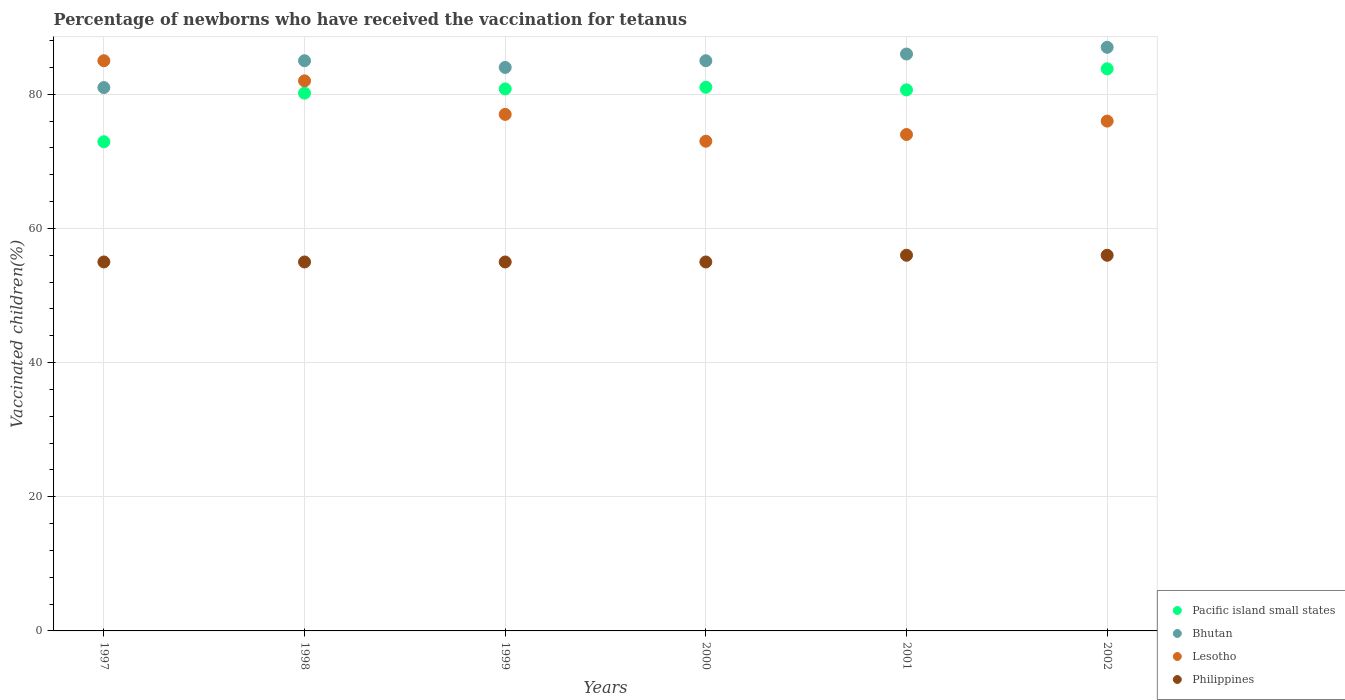How many different coloured dotlines are there?
Provide a short and direct response. 4. Is the number of dotlines equal to the number of legend labels?
Offer a very short reply. Yes. What is the percentage of vaccinated children in Philippines in 2000?
Ensure brevity in your answer.  55. Across all years, what is the maximum percentage of vaccinated children in Pacific island small states?
Your response must be concise. 83.8. Across all years, what is the minimum percentage of vaccinated children in Pacific island small states?
Offer a terse response. 72.92. In which year was the percentage of vaccinated children in Philippines maximum?
Your response must be concise. 2001. What is the total percentage of vaccinated children in Lesotho in the graph?
Give a very brief answer. 467. What is the difference between the percentage of vaccinated children in Pacific island small states in 1999 and that in 2002?
Keep it short and to the point. -3. What is the difference between the percentage of vaccinated children in Philippines in 1997 and the percentage of vaccinated children in Bhutan in 2000?
Your answer should be compact. -30. What is the average percentage of vaccinated children in Pacific island small states per year?
Your answer should be very brief. 79.9. In the year 2002, what is the difference between the percentage of vaccinated children in Philippines and percentage of vaccinated children in Bhutan?
Make the answer very short. -31. In how many years, is the percentage of vaccinated children in Philippines greater than 12 %?
Offer a very short reply. 6. What is the ratio of the percentage of vaccinated children in Philippines in 1999 to that in 2001?
Your answer should be compact. 0.98. Is the percentage of vaccinated children in Bhutan in 1999 less than that in 2000?
Offer a very short reply. Yes. What is the difference between the highest and the lowest percentage of vaccinated children in Pacific island small states?
Your response must be concise. 10.87. Is the sum of the percentage of vaccinated children in Philippines in 1997 and 2001 greater than the maximum percentage of vaccinated children in Lesotho across all years?
Your answer should be compact. Yes. Is the percentage of vaccinated children in Philippines strictly greater than the percentage of vaccinated children in Bhutan over the years?
Your response must be concise. No. What is the difference between two consecutive major ticks on the Y-axis?
Offer a terse response. 20. Are the values on the major ticks of Y-axis written in scientific E-notation?
Your answer should be compact. No. Does the graph contain grids?
Your answer should be compact. Yes. Where does the legend appear in the graph?
Keep it short and to the point. Bottom right. How many legend labels are there?
Your response must be concise. 4. What is the title of the graph?
Give a very brief answer. Percentage of newborns who have received the vaccination for tetanus. What is the label or title of the X-axis?
Provide a short and direct response. Years. What is the label or title of the Y-axis?
Offer a terse response. Vaccinated children(%). What is the Vaccinated children(%) in Pacific island small states in 1997?
Your response must be concise. 72.92. What is the Vaccinated children(%) of Lesotho in 1997?
Provide a succinct answer. 85. What is the Vaccinated children(%) in Pacific island small states in 1998?
Keep it short and to the point. 80.16. What is the Vaccinated children(%) in Bhutan in 1998?
Provide a succinct answer. 85. What is the Vaccinated children(%) of Pacific island small states in 1999?
Offer a terse response. 80.8. What is the Vaccinated children(%) of Bhutan in 1999?
Your answer should be compact. 84. What is the Vaccinated children(%) in Lesotho in 1999?
Provide a succinct answer. 77. What is the Vaccinated children(%) of Pacific island small states in 2000?
Make the answer very short. 81.04. What is the Vaccinated children(%) in Bhutan in 2000?
Keep it short and to the point. 85. What is the Vaccinated children(%) in Philippines in 2000?
Provide a short and direct response. 55. What is the Vaccinated children(%) in Pacific island small states in 2001?
Keep it short and to the point. 80.65. What is the Vaccinated children(%) of Bhutan in 2001?
Make the answer very short. 86. What is the Vaccinated children(%) of Pacific island small states in 2002?
Provide a succinct answer. 83.8. What is the Vaccinated children(%) in Lesotho in 2002?
Make the answer very short. 76. What is the Vaccinated children(%) in Philippines in 2002?
Your answer should be compact. 56. Across all years, what is the maximum Vaccinated children(%) of Pacific island small states?
Provide a short and direct response. 83.8. Across all years, what is the maximum Vaccinated children(%) of Bhutan?
Offer a terse response. 87. Across all years, what is the maximum Vaccinated children(%) of Lesotho?
Give a very brief answer. 85. Across all years, what is the minimum Vaccinated children(%) of Pacific island small states?
Provide a succinct answer. 72.92. Across all years, what is the minimum Vaccinated children(%) of Bhutan?
Provide a succinct answer. 81. What is the total Vaccinated children(%) of Pacific island small states in the graph?
Ensure brevity in your answer.  479.38. What is the total Vaccinated children(%) of Bhutan in the graph?
Offer a very short reply. 508. What is the total Vaccinated children(%) of Lesotho in the graph?
Your response must be concise. 467. What is the total Vaccinated children(%) in Philippines in the graph?
Your answer should be very brief. 332. What is the difference between the Vaccinated children(%) in Pacific island small states in 1997 and that in 1998?
Provide a succinct answer. -7.24. What is the difference between the Vaccinated children(%) of Bhutan in 1997 and that in 1998?
Give a very brief answer. -4. What is the difference between the Vaccinated children(%) of Lesotho in 1997 and that in 1998?
Provide a succinct answer. 3. What is the difference between the Vaccinated children(%) of Philippines in 1997 and that in 1998?
Provide a succinct answer. 0. What is the difference between the Vaccinated children(%) of Pacific island small states in 1997 and that in 1999?
Offer a very short reply. -7.88. What is the difference between the Vaccinated children(%) of Lesotho in 1997 and that in 1999?
Your answer should be compact. 8. What is the difference between the Vaccinated children(%) of Philippines in 1997 and that in 1999?
Keep it short and to the point. 0. What is the difference between the Vaccinated children(%) in Pacific island small states in 1997 and that in 2000?
Offer a terse response. -8.12. What is the difference between the Vaccinated children(%) of Bhutan in 1997 and that in 2000?
Your response must be concise. -4. What is the difference between the Vaccinated children(%) in Pacific island small states in 1997 and that in 2001?
Provide a succinct answer. -7.73. What is the difference between the Vaccinated children(%) in Bhutan in 1997 and that in 2001?
Keep it short and to the point. -5. What is the difference between the Vaccinated children(%) in Philippines in 1997 and that in 2001?
Provide a succinct answer. -1. What is the difference between the Vaccinated children(%) in Pacific island small states in 1997 and that in 2002?
Provide a succinct answer. -10.87. What is the difference between the Vaccinated children(%) in Bhutan in 1997 and that in 2002?
Offer a very short reply. -6. What is the difference between the Vaccinated children(%) in Pacific island small states in 1998 and that in 1999?
Ensure brevity in your answer.  -0.63. What is the difference between the Vaccinated children(%) of Bhutan in 1998 and that in 1999?
Your response must be concise. 1. What is the difference between the Vaccinated children(%) in Pacific island small states in 1998 and that in 2000?
Provide a succinct answer. -0.88. What is the difference between the Vaccinated children(%) in Pacific island small states in 1998 and that in 2001?
Your answer should be compact. -0.49. What is the difference between the Vaccinated children(%) in Philippines in 1998 and that in 2001?
Your answer should be compact. -1. What is the difference between the Vaccinated children(%) of Pacific island small states in 1998 and that in 2002?
Provide a short and direct response. -3.63. What is the difference between the Vaccinated children(%) of Bhutan in 1998 and that in 2002?
Make the answer very short. -2. What is the difference between the Vaccinated children(%) in Lesotho in 1998 and that in 2002?
Give a very brief answer. 6. What is the difference between the Vaccinated children(%) of Pacific island small states in 1999 and that in 2000?
Provide a succinct answer. -0.25. What is the difference between the Vaccinated children(%) in Bhutan in 1999 and that in 2000?
Provide a succinct answer. -1. What is the difference between the Vaccinated children(%) of Lesotho in 1999 and that in 2000?
Offer a very short reply. 4. What is the difference between the Vaccinated children(%) of Pacific island small states in 1999 and that in 2001?
Your response must be concise. 0.14. What is the difference between the Vaccinated children(%) in Lesotho in 1999 and that in 2001?
Give a very brief answer. 3. What is the difference between the Vaccinated children(%) in Philippines in 1999 and that in 2001?
Keep it short and to the point. -1. What is the difference between the Vaccinated children(%) of Pacific island small states in 1999 and that in 2002?
Give a very brief answer. -3. What is the difference between the Vaccinated children(%) of Bhutan in 1999 and that in 2002?
Offer a terse response. -3. What is the difference between the Vaccinated children(%) of Philippines in 1999 and that in 2002?
Your answer should be compact. -1. What is the difference between the Vaccinated children(%) in Pacific island small states in 2000 and that in 2001?
Keep it short and to the point. 0.39. What is the difference between the Vaccinated children(%) in Philippines in 2000 and that in 2001?
Keep it short and to the point. -1. What is the difference between the Vaccinated children(%) of Pacific island small states in 2000 and that in 2002?
Your response must be concise. -2.75. What is the difference between the Vaccinated children(%) in Lesotho in 2000 and that in 2002?
Keep it short and to the point. -3. What is the difference between the Vaccinated children(%) of Pacific island small states in 2001 and that in 2002?
Offer a terse response. -3.14. What is the difference between the Vaccinated children(%) in Lesotho in 2001 and that in 2002?
Make the answer very short. -2. What is the difference between the Vaccinated children(%) of Pacific island small states in 1997 and the Vaccinated children(%) of Bhutan in 1998?
Ensure brevity in your answer.  -12.08. What is the difference between the Vaccinated children(%) in Pacific island small states in 1997 and the Vaccinated children(%) in Lesotho in 1998?
Your response must be concise. -9.08. What is the difference between the Vaccinated children(%) of Pacific island small states in 1997 and the Vaccinated children(%) of Philippines in 1998?
Keep it short and to the point. 17.92. What is the difference between the Vaccinated children(%) of Lesotho in 1997 and the Vaccinated children(%) of Philippines in 1998?
Your answer should be compact. 30. What is the difference between the Vaccinated children(%) in Pacific island small states in 1997 and the Vaccinated children(%) in Bhutan in 1999?
Your response must be concise. -11.08. What is the difference between the Vaccinated children(%) of Pacific island small states in 1997 and the Vaccinated children(%) of Lesotho in 1999?
Offer a very short reply. -4.08. What is the difference between the Vaccinated children(%) in Pacific island small states in 1997 and the Vaccinated children(%) in Philippines in 1999?
Keep it short and to the point. 17.92. What is the difference between the Vaccinated children(%) of Bhutan in 1997 and the Vaccinated children(%) of Philippines in 1999?
Keep it short and to the point. 26. What is the difference between the Vaccinated children(%) in Lesotho in 1997 and the Vaccinated children(%) in Philippines in 1999?
Provide a short and direct response. 30. What is the difference between the Vaccinated children(%) in Pacific island small states in 1997 and the Vaccinated children(%) in Bhutan in 2000?
Provide a short and direct response. -12.08. What is the difference between the Vaccinated children(%) in Pacific island small states in 1997 and the Vaccinated children(%) in Lesotho in 2000?
Your answer should be very brief. -0.08. What is the difference between the Vaccinated children(%) in Pacific island small states in 1997 and the Vaccinated children(%) in Philippines in 2000?
Keep it short and to the point. 17.92. What is the difference between the Vaccinated children(%) of Lesotho in 1997 and the Vaccinated children(%) of Philippines in 2000?
Ensure brevity in your answer.  30. What is the difference between the Vaccinated children(%) in Pacific island small states in 1997 and the Vaccinated children(%) in Bhutan in 2001?
Make the answer very short. -13.08. What is the difference between the Vaccinated children(%) of Pacific island small states in 1997 and the Vaccinated children(%) of Lesotho in 2001?
Keep it short and to the point. -1.08. What is the difference between the Vaccinated children(%) in Pacific island small states in 1997 and the Vaccinated children(%) in Philippines in 2001?
Offer a terse response. 16.92. What is the difference between the Vaccinated children(%) of Bhutan in 1997 and the Vaccinated children(%) of Philippines in 2001?
Provide a succinct answer. 25. What is the difference between the Vaccinated children(%) of Pacific island small states in 1997 and the Vaccinated children(%) of Bhutan in 2002?
Your response must be concise. -14.08. What is the difference between the Vaccinated children(%) of Pacific island small states in 1997 and the Vaccinated children(%) of Lesotho in 2002?
Keep it short and to the point. -3.08. What is the difference between the Vaccinated children(%) in Pacific island small states in 1997 and the Vaccinated children(%) in Philippines in 2002?
Your response must be concise. 16.92. What is the difference between the Vaccinated children(%) of Bhutan in 1997 and the Vaccinated children(%) of Lesotho in 2002?
Your response must be concise. 5. What is the difference between the Vaccinated children(%) of Lesotho in 1997 and the Vaccinated children(%) of Philippines in 2002?
Provide a succinct answer. 29. What is the difference between the Vaccinated children(%) of Pacific island small states in 1998 and the Vaccinated children(%) of Bhutan in 1999?
Your answer should be very brief. -3.84. What is the difference between the Vaccinated children(%) of Pacific island small states in 1998 and the Vaccinated children(%) of Lesotho in 1999?
Your response must be concise. 3.16. What is the difference between the Vaccinated children(%) in Pacific island small states in 1998 and the Vaccinated children(%) in Philippines in 1999?
Provide a succinct answer. 25.16. What is the difference between the Vaccinated children(%) of Bhutan in 1998 and the Vaccinated children(%) of Lesotho in 1999?
Your answer should be very brief. 8. What is the difference between the Vaccinated children(%) in Bhutan in 1998 and the Vaccinated children(%) in Philippines in 1999?
Give a very brief answer. 30. What is the difference between the Vaccinated children(%) in Lesotho in 1998 and the Vaccinated children(%) in Philippines in 1999?
Your answer should be compact. 27. What is the difference between the Vaccinated children(%) of Pacific island small states in 1998 and the Vaccinated children(%) of Bhutan in 2000?
Make the answer very short. -4.84. What is the difference between the Vaccinated children(%) of Pacific island small states in 1998 and the Vaccinated children(%) of Lesotho in 2000?
Provide a succinct answer. 7.16. What is the difference between the Vaccinated children(%) in Pacific island small states in 1998 and the Vaccinated children(%) in Philippines in 2000?
Offer a terse response. 25.16. What is the difference between the Vaccinated children(%) of Bhutan in 1998 and the Vaccinated children(%) of Lesotho in 2000?
Your answer should be very brief. 12. What is the difference between the Vaccinated children(%) in Bhutan in 1998 and the Vaccinated children(%) in Philippines in 2000?
Keep it short and to the point. 30. What is the difference between the Vaccinated children(%) of Lesotho in 1998 and the Vaccinated children(%) of Philippines in 2000?
Provide a succinct answer. 27. What is the difference between the Vaccinated children(%) of Pacific island small states in 1998 and the Vaccinated children(%) of Bhutan in 2001?
Keep it short and to the point. -5.84. What is the difference between the Vaccinated children(%) in Pacific island small states in 1998 and the Vaccinated children(%) in Lesotho in 2001?
Provide a short and direct response. 6.16. What is the difference between the Vaccinated children(%) in Pacific island small states in 1998 and the Vaccinated children(%) in Philippines in 2001?
Provide a succinct answer. 24.16. What is the difference between the Vaccinated children(%) of Bhutan in 1998 and the Vaccinated children(%) of Lesotho in 2001?
Provide a short and direct response. 11. What is the difference between the Vaccinated children(%) in Lesotho in 1998 and the Vaccinated children(%) in Philippines in 2001?
Offer a very short reply. 26. What is the difference between the Vaccinated children(%) in Pacific island small states in 1998 and the Vaccinated children(%) in Bhutan in 2002?
Provide a short and direct response. -6.84. What is the difference between the Vaccinated children(%) of Pacific island small states in 1998 and the Vaccinated children(%) of Lesotho in 2002?
Ensure brevity in your answer.  4.16. What is the difference between the Vaccinated children(%) in Pacific island small states in 1998 and the Vaccinated children(%) in Philippines in 2002?
Keep it short and to the point. 24.16. What is the difference between the Vaccinated children(%) of Bhutan in 1998 and the Vaccinated children(%) of Lesotho in 2002?
Your response must be concise. 9. What is the difference between the Vaccinated children(%) in Lesotho in 1998 and the Vaccinated children(%) in Philippines in 2002?
Offer a very short reply. 26. What is the difference between the Vaccinated children(%) of Pacific island small states in 1999 and the Vaccinated children(%) of Bhutan in 2000?
Give a very brief answer. -4.2. What is the difference between the Vaccinated children(%) of Pacific island small states in 1999 and the Vaccinated children(%) of Lesotho in 2000?
Your answer should be compact. 7.8. What is the difference between the Vaccinated children(%) of Pacific island small states in 1999 and the Vaccinated children(%) of Philippines in 2000?
Keep it short and to the point. 25.8. What is the difference between the Vaccinated children(%) in Bhutan in 1999 and the Vaccinated children(%) in Lesotho in 2000?
Your answer should be very brief. 11. What is the difference between the Vaccinated children(%) of Bhutan in 1999 and the Vaccinated children(%) of Philippines in 2000?
Offer a terse response. 29. What is the difference between the Vaccinated children(%) in Pacific island small states in 1999 and the Vaccinated children(%) in Bhutan in 2001?
Offer a very short reply. -5.2. What is the difference between the Vaccinated children(%) of Pacific island small states in 1999 and the Vaccinated children(%) of Lesotho in 2001?
Your answer should be compact. 6.8. What is the difference between the Vaccinated children(%) in Pacific island small states in 1999 and the Vaccinated children(%) in Philippines in 2001?
Give a very brief answer. 24.8. What is the difference between the Vaccinated children(%) of Lesotho in 1999 and the Vaccinated children(%) of Philippines in 2001?
Your response must be concise. 21. What is the difference between the Vaccinated children(%) of Pacific island small states in 1999 and the Vaccinated children(%) of Bhutan in 2002?
Your answer should be very brief. -6.2. What is the difference between the Vaccinated children(%) in Pacific island small states in 1999 and the Vaccinated children(%) in Lesotho in 2002?
Keep it short and to the point. 4.8. What is the difference between the Vaccinated children(%) in Pacific island small states in 1999 and the Vaccinated children(%) in Philippines in 2002?
Your response must be concise. 24.8. What is the difference between the Vaccinated children(%) of Lesotho in 1999 and the Vaccinated children(%) of Philippines in 2002?
Ensure brevity in your answer.  21. What is the difference between the Vaccinated children(%) in Pacific island small states in 2000 and the Vaccinated children(%) in Bhutan in 2001?
Offer a very short reply. -4.96. What is the difference between the Vaccinated children(%) in Pacific island small states in 2000 and the Vaccinated children(%) in Lesotho in 2001?
Provide a short and direct response. 7.04. What is the difference between the Vaccinated children(%) of Pacific island small states in 2000 and the Vaccinated children(%) of Philippines in 2001?
Make the answer very short. 25.04. What is the difference between the Vaccinated children(%) of Bhutan in 2000 and the Vaccinated children(%) of Lesotho in 2001?
Your answer should be compact. 11. What is the difference between the Vaccinated children(%) of Lesotho in 2000 and the Vaccinated children(%) of Philippines in 2001?
Your response must be concise. 17. What is the difference between the Vaccinated children(%) in Pacific island small states in 2000 and the Vaccinated children(%) in Bhutan in 2002?
Your answer should be compact. -5.96. What is the difference between the Vaccinated children(%) of Pacific island small states in 2000 and the Vaccinated children(%) of Lesotho in 2002?
Your answer should be very brief. 5.04. What is the difference between the Vaccinated children(%) in Pacific island small states in 2000 and the Vaccinated children(%) in Philippines in 2002?
Your answer should be very brief. 25.04. What is the difference between the Vaccinated children(%) in Bhutan in 2000 and the Vaccinated children(%) in Philippines in 2002?
Ensure brevity in your answer.  29. What is the difference between the Vaccinated children(%) of Pacific island small states in 2001 and the Vaccinated children(%) of Bhutan in 2002?
Offer a terse response. -6.34. What is the difference between the Vaccinated children(%) of Pacific island small states in 2001 and the Vaccinated children(%) of Lesotho in 2002?
Your response must be concise. 4.66. What is the difference between the Vaccinated children(%) in Pacific island small states in 2001 and the Vaccinated children(%) in Philippines in 2002?
Your answer should be very brief. 24.66. What is the difference between the Vaccinated children(%) of Bhutan in 2001 and the Vaccinated children(%) of Philippines in 2002?
Your response must be concise. 30. What is the difference between the Vaccinated children(%) in Lesotho in 2001 and the Vaccinated children(%) in Philippines in 2002?
Give a very brief answer. 18. What is the average Vaccinated children(%) in Pacific island small states per year?
Ensure brevity in your answer.  79.9. What is the average Vaccinated children(%) of Bhutan per year?
Offer a terse response. 84.67. What is the average Vaccinated children(%) in Lesotho per year?
Your answer should be very brief. 77.83. What is the average Vaccinated children(%) of Philippines per year?
Give a very brief answer. 55.33. In the year 1997, what is the difference between the Vaccinated children(%) in Pacific island small states and Vaccinated children(%) in Bhutan?
Your answer should be compact. -8.08. In the year 1997, what is the difference between the Vaccinated children(%) of Pacific island small states and Vaccinated children(%) of Lesotho?
Offer a very short reply. -12.08. In the year 1997, what is the difference between the Vaccinated children(%) of Pacific island small states and Vaccinated children(%) of Philippines?
Give a very brief answer. 17.92. In the year 1997, what is the difference between the Vaccinated children(%) of Bhutan and Vaccinated children(%) of Lesotho?
Your response must be concise. -4. In the year 1997, what is the difference between the Vaccinated children(%) in Bhutan and Vaccinated children(%) in Philippines?
Make the answer very short. 26. In the year 1998, what is the difference between the Vaccinated children(%) of Pacific island small states and Vaccinated children(%) of Bhutan?
Your answer should be compact. -4.84. In the year 1998, what is the difference between the Vaccinated children(%) in Pacific island small states and Vaccinated children(%) in Lesotho?
Your answer should be compact. -1.84. In the year 1998, what is the difference between the Vaccinated children(%) of Pacific island small states and Vaccinated children(%) of Philippines?
Give a very brief answer. 25.16. In the year 1998, what is the difference between the Vaccinated children(%) in Bhutan and Vaccinated children(%) in Lesotho?
Provide a short and direct response. 3. In the year 1998, what is the difference between the Vaccinated children(%) in Lesotho and Vaccinated children(%) in Philippines?
Make the answer very short. 27. In the year 1999, what is the difference between the Vaccinated children(%) in Pacific island small states and Vaccinated children(%) in Bhutan?
Your response must be concise. -3.2. In the year 1999, what is the difference between the Vaccinated children(%) of Pacific island small states and Vaccinated children(%) of Lesotho?
Ensure brevity in your answer.  3.8. In the year 1999, what is the difference between the Vaccinated children(%) in Pacific island small states and Vaccinated children(%) in Philippines?
Your answer should be compact. 25.8. In the year 1999, what is the difference between the Vaccinated children(%) in Bhutan and Vaccinated children(%) in Philippines?
Offer a terse response. 29. In the year 2000, what is the difference between the Vaccinated children(%) of Pacific island small states and Vaccinated children(%) of Bhutan?
Ensure brevity in your answer.  -3.96. In the year 2000, what is the difference between the Vaccinated children(%) in Pacific island small states and Vaccinated children(%) in Lesotho?
Give a very brief answer. 8.04. In the year 2000, what is the difference between the Vaccinated children(%) of Pacific island small states and Vaccinated children(%) of Philippines?
Give a very brief answer. 26.04. In the year 2000, what is the difference between the Vaccinated children(%) in Lesotho and Vaccinated children(%) in Philippines?
Keep it short and to the point. 18. In the year 2001, what is the difference between the Vaccinated children(%) of Pacific island small states and Vaccinated children(%) of Bhutan?
Your answer should be very brief. -5.34. In the year 2001, what is the difference between the Vaccinated children(%) of Pacific island small states and Vaccinated children(%) of Lesotho?
Your response must be concise. 6.66. In the year 2001, what is the difference between the Vaccinated children(%) in Pacific island small states and Vaccinated children(%) in Philippines?
Provide a short and direct response. 24.66. In the year 2001, what is the difference between the Vaccinated children(%) of Lesotho and Vaccinated children(%) of Philippines?
Give a very brief answer. 18. In the year 2002, what is the difference between the Vaccinated children(%) in Pacific island small states and Vaccinated children(%) in Bhutan?
Make the answer very short. -3.2. In the year 2002, what is the difference between the Vaccinated children(%) of Pacific island small states and Vaccinated children(%) of Lesotho?
Keep it short and to the point. 7.8. In the year 2002, what is the difference between the Vaccinated children(%) in Pacific island small states and Vaccinated children(%) in Philippines?
Your answer should be very brief. 27.8. What is the ratio of the Vaccinated children(%) in Pacific island small states in 1997 to that in 1998?
Give a very brief answer. 0.91. What is the ratio of the Vaccinated children(%) of Bhutan in 1997 to that in 1998?
Offer a very short reply. 0.95. What is the ratio of the Vaccinated children(%) of Lesotho in 1997 to that in 1998?
Your response must be concise. 1.04. What is the ratio of the Vaccinated children(%) of Philippines in 1997 to that in 1998?
Make the answer very short. 1. What is the ratio of the Vaccinated children(%) in Pacific island small states in 1997 to that in 1999?
Ensure brevity in your answer.  0.9. What is the ratio of the Vaccinated children(%) of Lesotho in 1997 to that in 1999?
Offer a very short reply. 1.1. What is the ratio of the Vaccinated children(%) in Pacific island small states in 1997 to that in 2000?
Ensure brevity in your answer.  0.9. What is the ratio of the Vaccinated children(%) in Bhutan in 1997 to that in 2000?
Provide a succinct answer. 0.95. What is the ratio of the Vaccinated children(%) of Lesotho in 1997 to that in 2000?
Offer a very short reply. 1.16. What is the ratio of the Vaccinated children(%) of Philippines in 1997 to that in 2000?
Provide a succinct answer. 1. What is the ratio of the Vaccinated children(%) in Pacific island small states in 1997 to that in 2001?
Keep it short and to the point. 0.9. What is the ratio of the Vaccinated children(%) in Bhutan in 1997 to that in 2001?
Offer a terse response. 0.94. What is the ratio of the Vaccinated children(%) of Lesotho in 1997 to that in 2001?
Provide a short and direct response. 1.15. What is the ratio of the Vaccinated children(%) in Philippines in 1997 to that in 2001?
Make the answer very short. 0.98. What is the ratio of the Vaccinated children(%) in Pacific island small states in 1997 to that in 2002?
Provide a short and direct response. 0.87. What is the ratio of the Vaccinated children(%) of Lesotho in 1997 to that in 2002?
Provide a succinct answer. 1.12. What is the ratio of the Vaccinated children(%) of Philippines in 1997 to that in 2002?
Offer a very short reply. 0.98. What is the ratio of the Vaccinated children(%) of Pacific island small states in 1998 to that in 1999?
Provide a succinct answer. 0.99. What is the ratio of the Vaccinated children(%) in Bhutan in 1998 to that in 1999?
Ensure brevity in your answer.  1.01. What is the ratio of the Vaccinated children(%) in Lesotho in 1998 to that in 1999?
Offer a very short reply. 1.06. What is the ratio of the Vaccinated children(%) in Bhutan in 1998 to that in 2000?
Your answer should be compact. 1. What is the ratio of the Vaccinated children(%) in Lesotho in 1998 to that in 2000?
Give a very brief answer. 1.12. What is the ratio of the Vaccinated children(%) of Philippines in 1998 to that in 2000?
Provide a short and direct response. 1. What is the ratio of the Vaccinated children(%) in Bhutan in 1998 to that in 2001?
Provide a succinct answer. 0.99. What is the ratio of the Vaccinated children(%) in Lesotho in 1998 to that in 2001?
Provide a succinct answer. 1.11. What is the ratio of the Vaccinated children(%) of Philippines in 1998 to that in 2001?
Give a very brief answer. 0.98. What is the ratio of the Vaccinated children(%) in Pacific island small states in 1998 to that in 2002?
Provide a succinct answer. 0.96. What is the ratio of the Vaccinated children(%) of Lesotho in 1998 to that in 2002?
Make the answer very short. 1.08. What is the ratio of the Vaccinated children(%) in Philippines in 1998 to that in 2002?
Give a very brief answer. 0.98. What is the ratio of the Vaccinated children(%) of Bhutan in 1999 to that in 2000?
Provide a short and direct response. 0.99. What is the ratio of the Vaccinated children(%) of Lesotho in 1999 to that in 2000?
Provide a succinct answer. 1.05. What is the ratio of the Vaccinated children(%) of Pacific island small states in 1999 to that in 2001?
Provide a short and direct response. 1. What is the ratio of the Vaccinated children(%) in Bhutan in 1999 to that in 2001?
Your answer should be compact. 0.98. What is the ratio of the Vaccinated children(%) of Lesotho in 1999 to that in 2001?
Your response must be concise. 1.04. What is the ratio of the Vaccinated children(%) in Philippines in 1999 to that in 2001?
Offer a terse response. 0.98. What is the ratio of the Vaccinated children(%) in Pacific island small states in 1999 to that in 2002?
Your answer should be very brief. 0.96. What is the ratio of the Vaccinated children(%) of Bhutan in 1999 to that in 2002?
Offer a terse response. 0.97. What is the ratio of the Vaccinated children(%) in Lesotho in 1999 to that in 2002?
Ensure brevity in your answer.  1.01. What is the ratio of the Vaccinated children(%) of Philippines in 1999 to that in 2002?
Offer a very short reply. 0.98. What is the ratio of the Vaccinated children(%) of Pacific island small states in 2000 to that in 2001?
Give a very brief answer. 1. What is the ratio of the Vaccinated children(%) of Bhutan in 2000 to that in 2001?
Your response must be concise. 0.99. What is the ratio of the Vaccinated children(%) of Lesotho in 2000 to that in 2001?
Offer a very short reply. 0.99. What is the ratio of the Vaccinated children(%) of Philippines in 2000 to that in 2001?
Give a very brief answer. 0.98. What is the ratio of the Vaccinated children(%) of Pacific island small states in 2000 to that in 2002?
Your answer should be very brief. 0.97. What is the ratio of the Vaccinated children(%) in Lesotho in 2000 to that in 2002?
Provide a short and direct response. 0.96. What is the ratio of the Vaccinated children(%) of Philippines in 2000 to that in 2002?
Offer a very short reply. 0.98. What is the ratio of the Vaccinated children(%) of Pacific island small states in 2001 to that in 2002?
Provide a short and direct response. 0.96. What is the ratio of the Vaccinated children(%) in Bhutan in 2001 to that in 2002?
Your answer should be very brief. 0.99. What is the ratio of the Vaccinated children(%) in Lesotho in 2001 to that in 2002?
Your response must be concise. 0.97. What is the ratio of the Vaccinated children(%) of Philippines in 2001 to that in 2002?
Your answer should be compact. 1. What is the difference between the highest and the second highest Vaccinated children(%) of Pacific island small states?
Offer a very short reply. 2.75. What is the difference between the highest and the second highest Vaccinated children(%) of Bhutan?
Keep it short and to the point. 1. What is the difference between the highest and the lowest Vaccinated children(%) of Pacific island small states?
Your response must be concise. 10.87. What is the difference between the highest and the lowest Vaccinated children(%) in Bhutan?
Your answer should be very brief. 6. What is the difference between the highest and the lowest Vaccinated children(%) in Philippines?
Your answer should be compact. 1. 